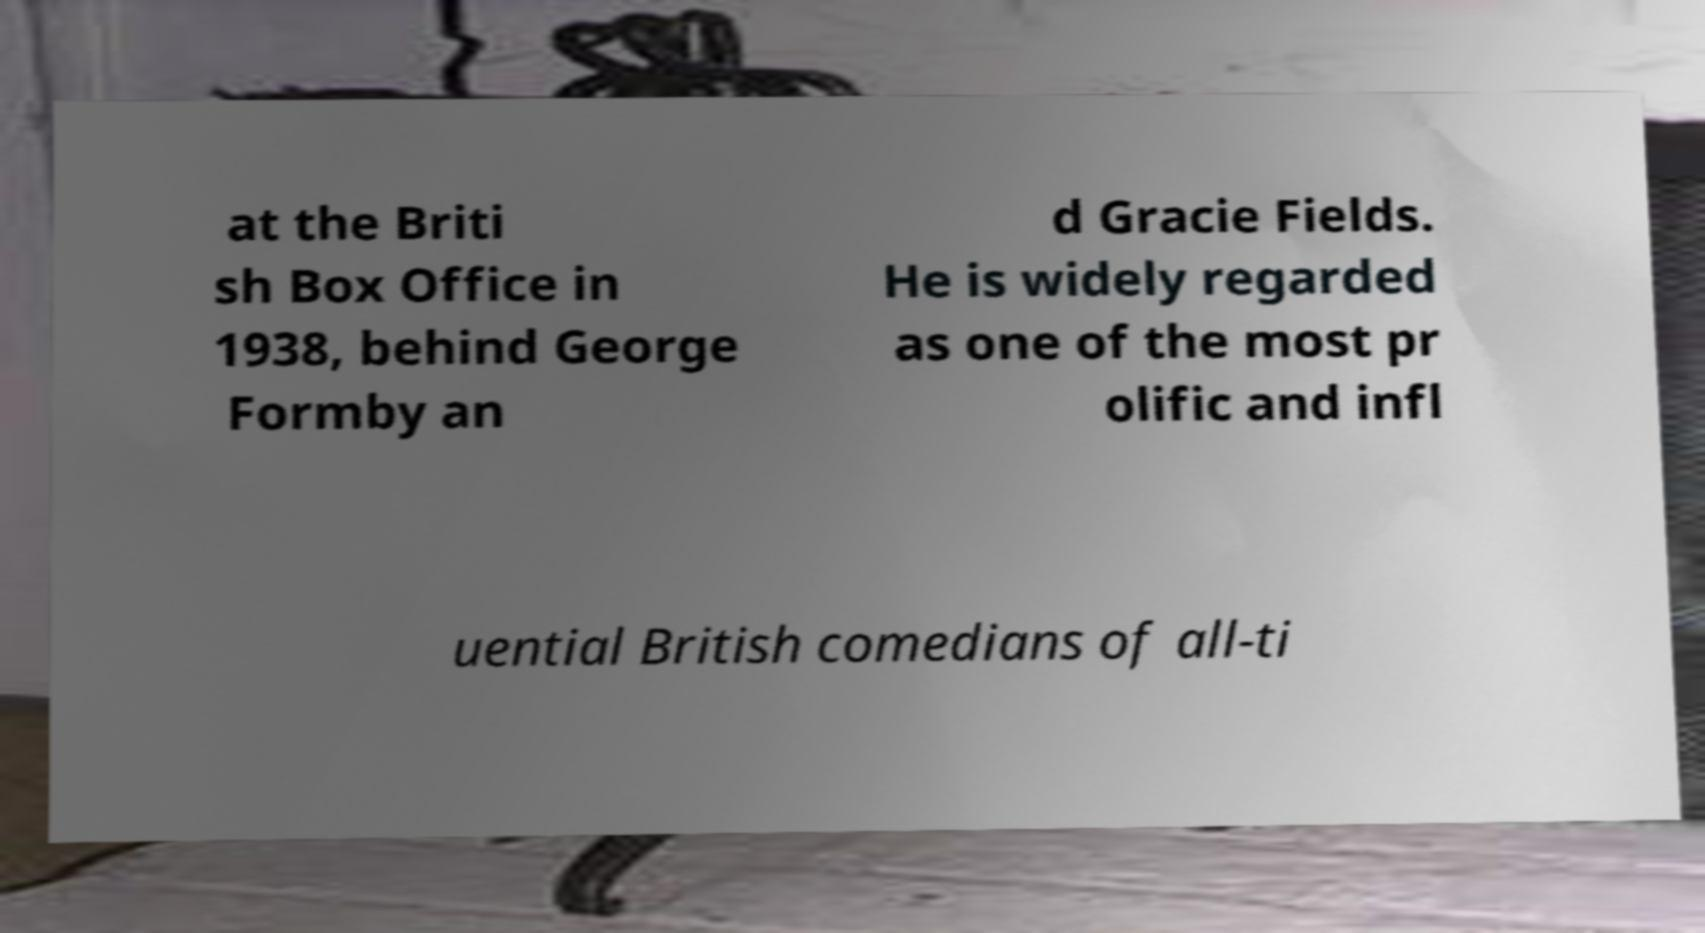Can you accurately transcribe the text from the provided image for me? at the Briti sh Box Office in 1938, behind George Formby an d Gracie Fields. He is widely regarded as one of the most pr olific and infl uential British comedians of all-ti 